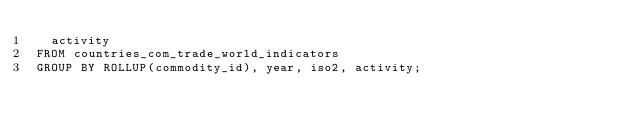Convert code to text. <code><loc_0><loc_0><loc_500><loc_500><_SQL_>  activity
FROM countries_com_trade_world_indicators
GROUP BY ROLLUP(commodity_id), year, iso2, activity;
</code> 